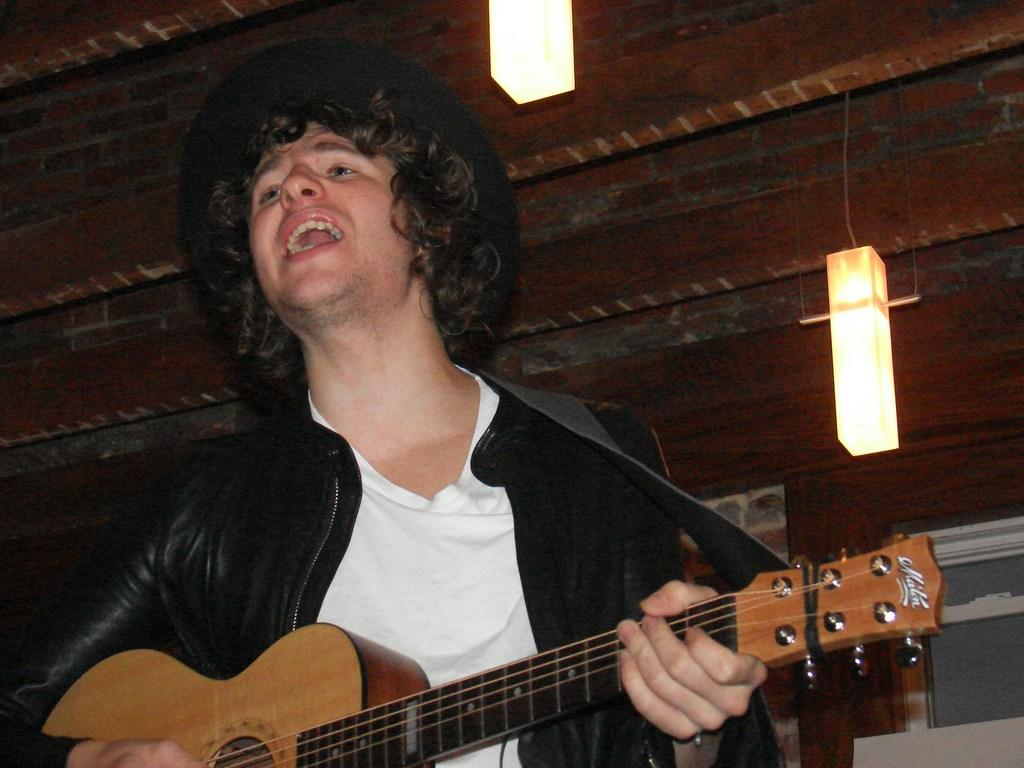What is the main subject of the image? There is a person in the image. What is the person wearing? The person is wearing a black jacket. What is the person doing in the image? The person is singing and playing a guitar. What can be seen in the background of the image? There are lights on the roof in the background. Are there any dinosaurs present at the party in the image? There is no party or dinosaurs present in the image; it features a person singing and playing a guitar. 